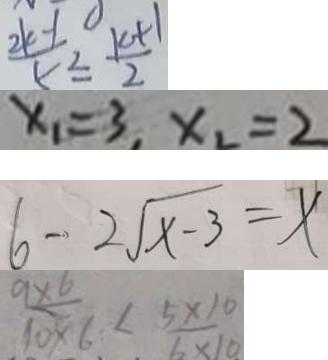<formula> <loc_0><loc_0><loc_500><loc_500>\frac { 2 k + 1 } { 5 } \leq \frac { k + 1 } { 2 } 
 x _ { 1 } = 3 , x _ { 2 } = 2 
 6 - 2 \sqrt { x - 3 } = x 
 \frac { 9 \times 6 } { 1 0 \times 6 } < \frac { 5 \times 1 0 } { 6 \times 1 0 }</formula> 